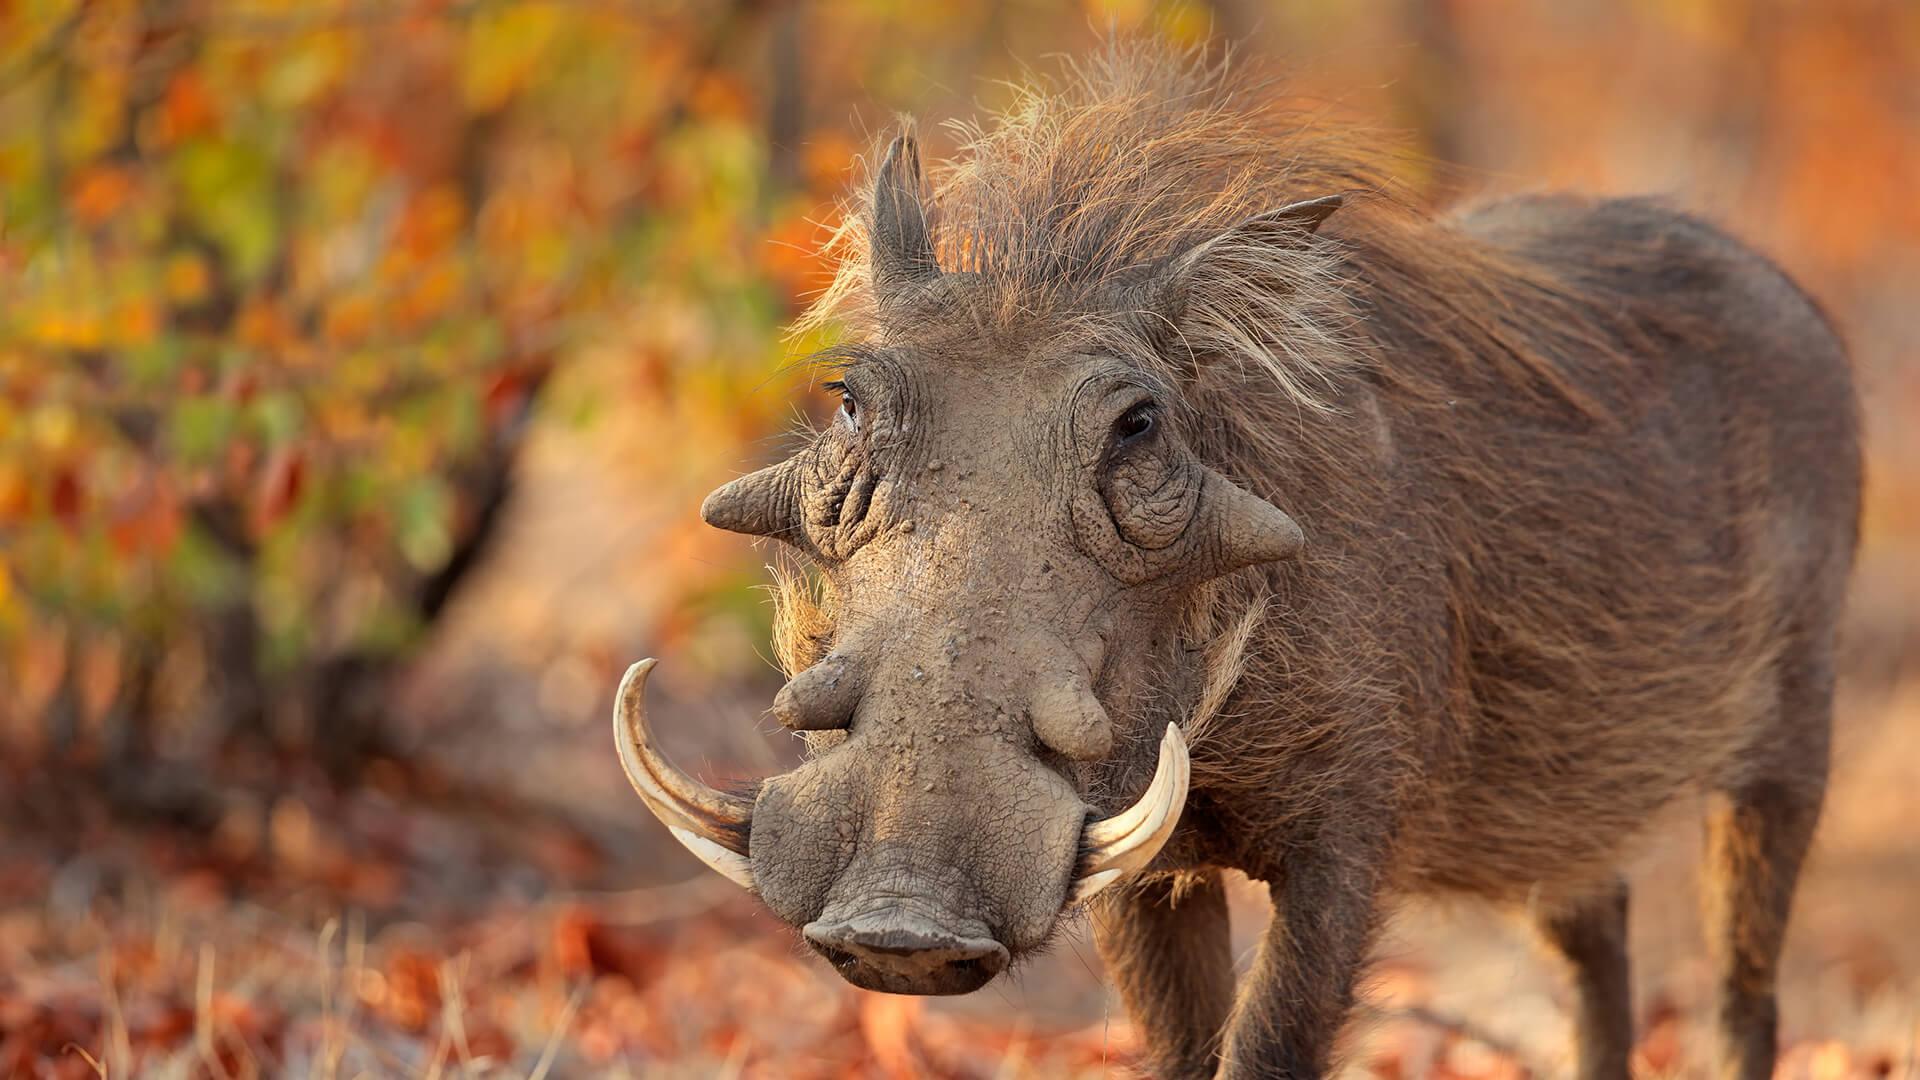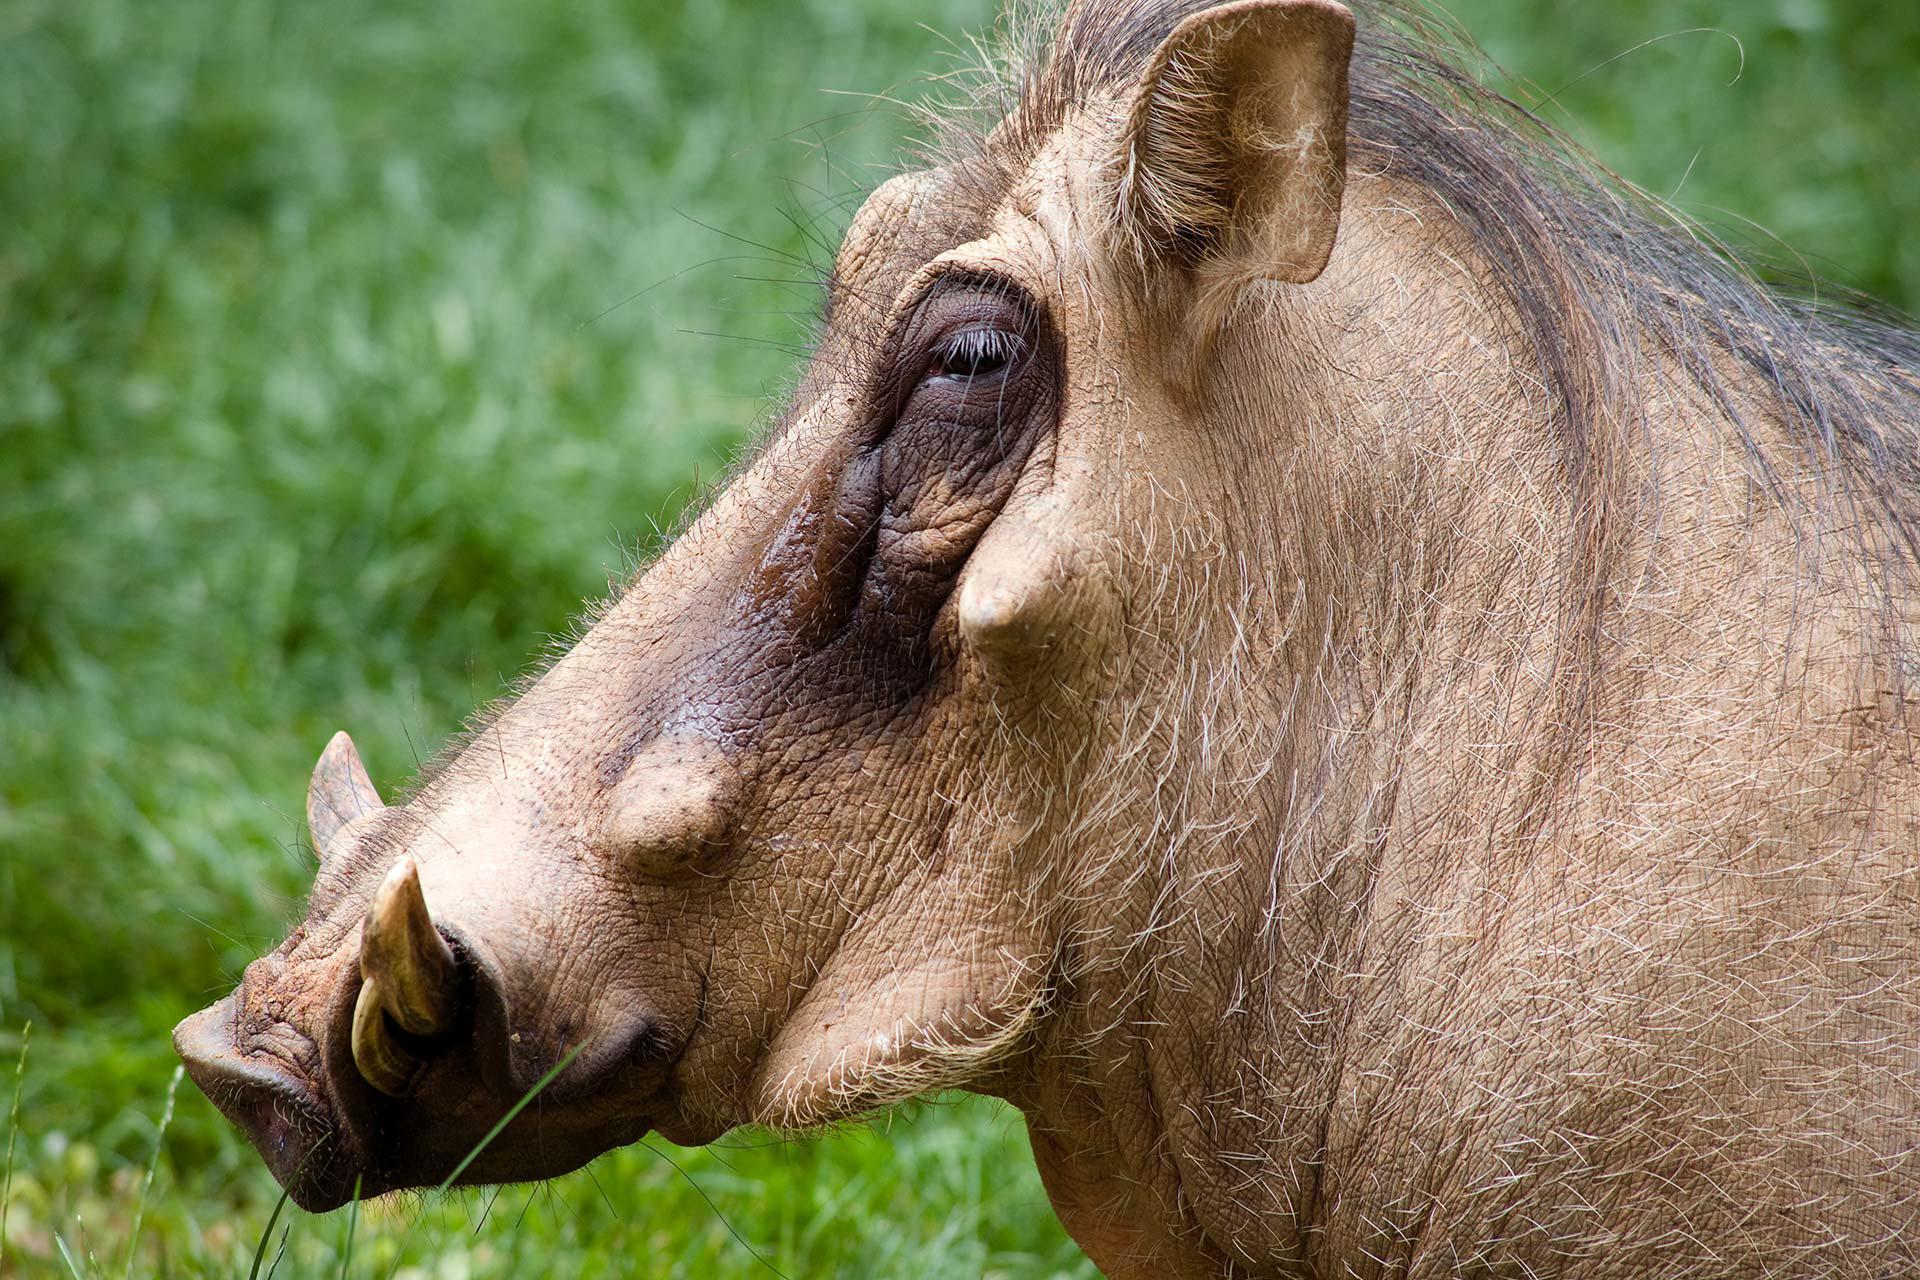The first image is the image on the left, the second image is the image on the right. Considering the images on both sides, is "The background of one of the images contains much more greenery than it's partner-image." valid? Answer yes or no. Yes. The first image is the image on the left, the second image is the image on the right. Considering the images on both sides, is "There is a dirt and tan colored boar in the grass who’s head is facing left." valid? Answer yes or no. Yes. 